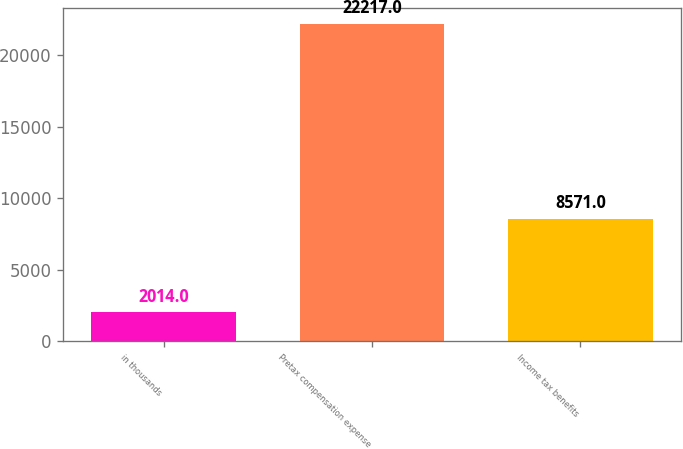Convert chart. <chart><loc_0><loc_0><loc_500><loc_500><bar_chart><fcel>in thousands<fcel>Pretax compensation expense<fcel>Income tax benefits<nl><fcel>2014<fcel>22217<fcel>8571<nl></chart> 